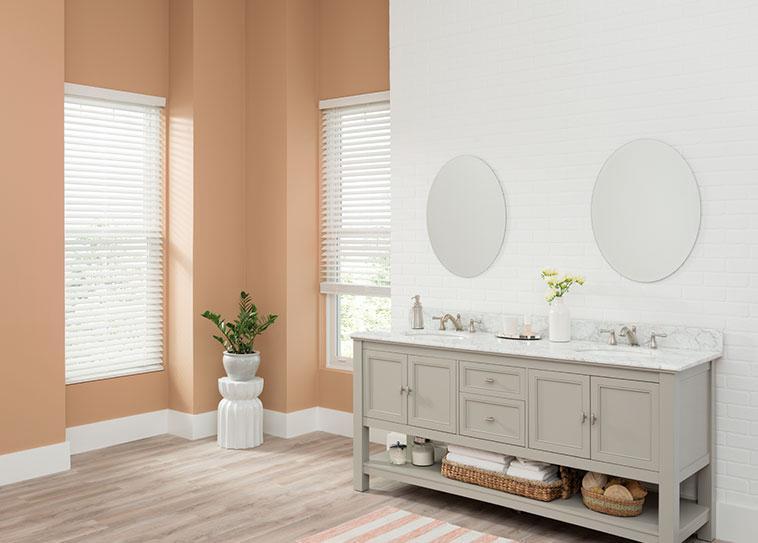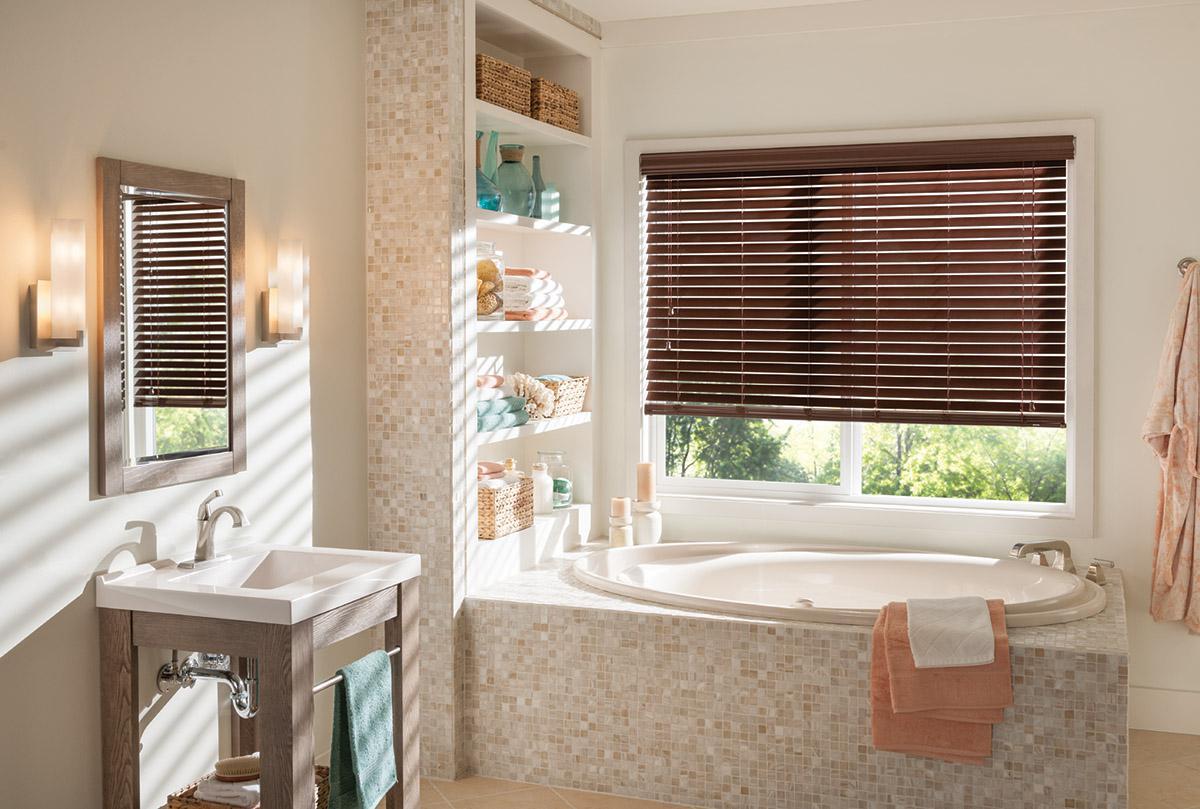The first image is the image on the left, the second image is the image on the right. Assess this claim about the two images: "The blinds in a room above a bathtub let in the light in the image on the left.". Correct or not? Answer yes or no. No. The first image is the image on the left, the second image is the image on the right. Evaluate the accuracy of this statement regarding the images: "There are two blinds.". Is it true? Answer yes or no. No. 